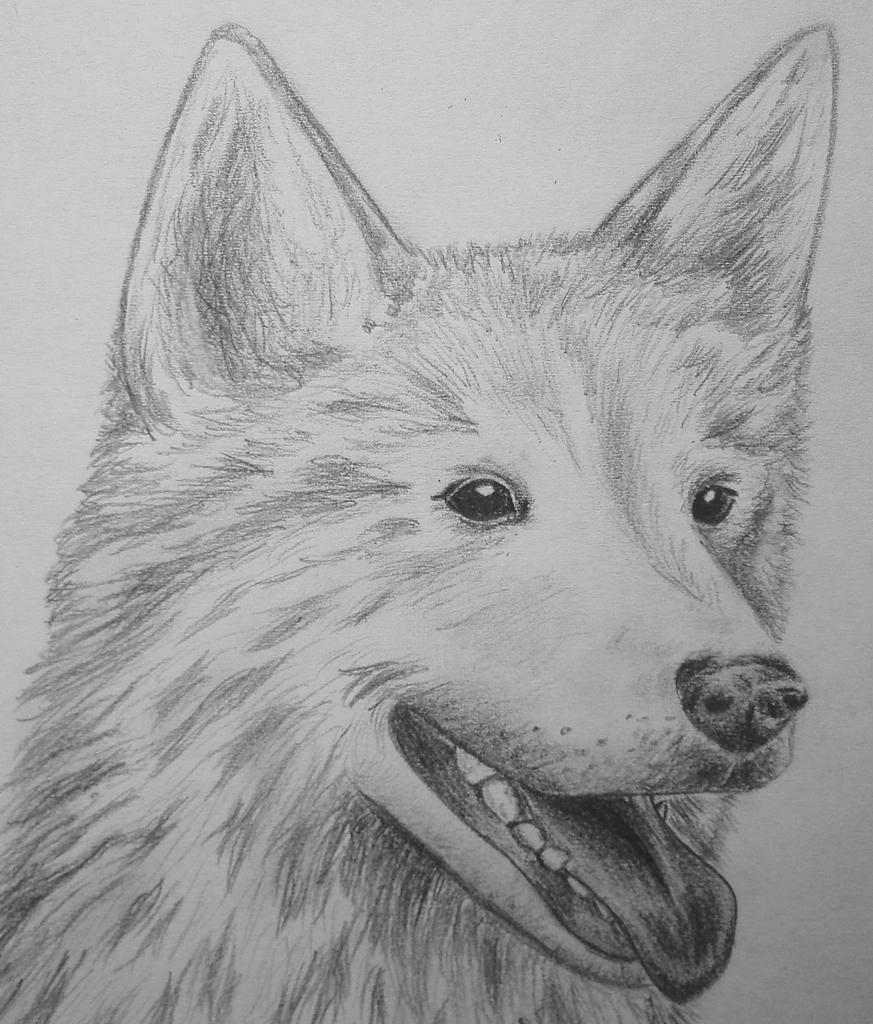What is depicted in the image? There is a drawing of a dog in the image. What type of ship can be seen sailing in the background of the image? There is no ship present in the image; it only contains a drawing of a dog. Can you tell me which vein is responsible for carrying oxygenated blood in the dog's drawing? The image is a drawing of a dog and does not show the internal anatomy of the dog, so it is not possible to determine which vein carries oxygenated blood. 